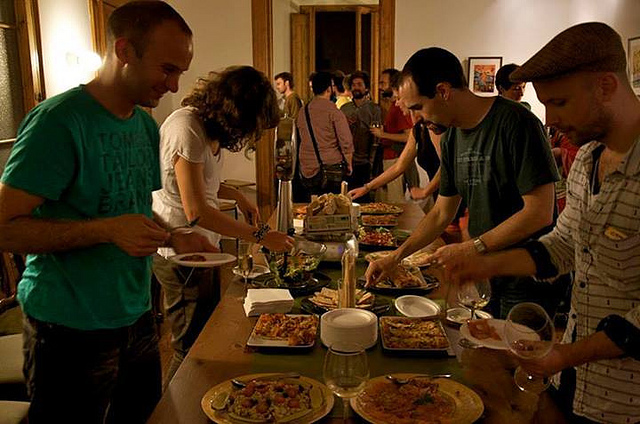<image>What pattern is on the outfit of the woman in the center? It is ambiguous what pattern is on the outfit of the woman in the center. It can be plain, lacy, solid or there might be no pattern at all. What pattern is on the outfit of the woman in the center? I am not sure what pattern is on the outfit of the woman in the center. It can be plain, lacy, or solid. 